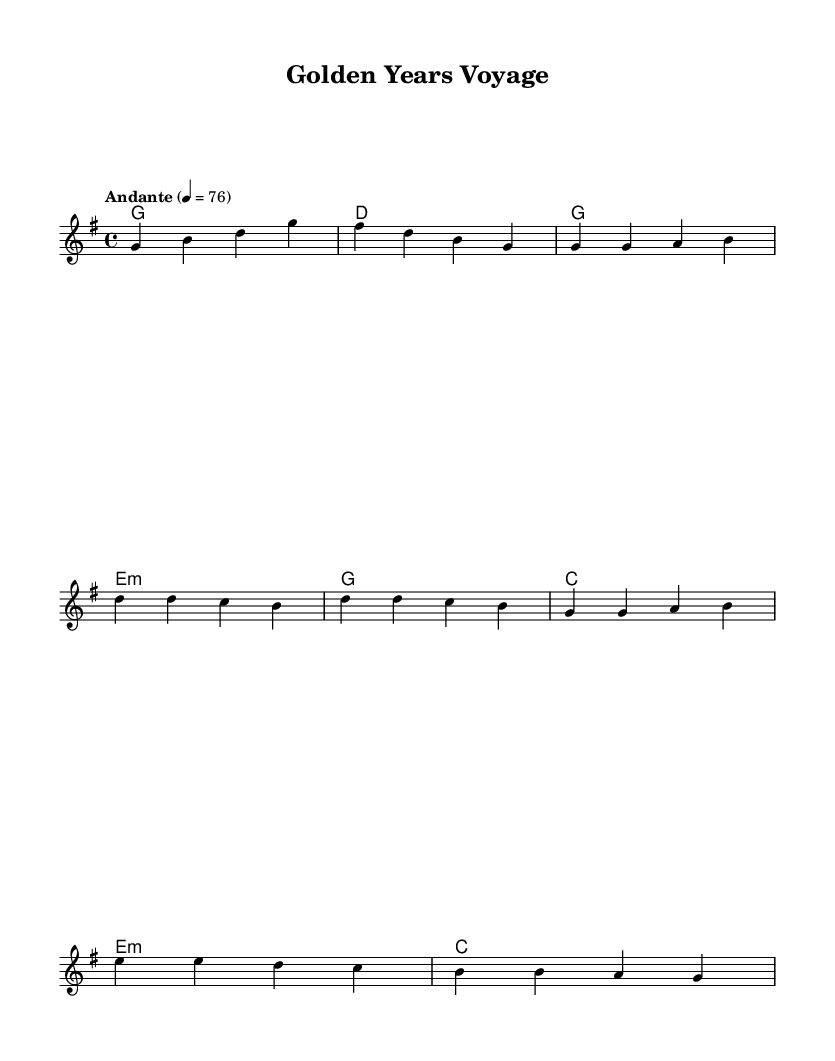What is the key signature of this music? The key signature is G major, which has one sharp (F#).
Answer: G major What is the time signature of this music? The time signature is 4/4, meaning there are four beats per measure.
Answer: 4/4 What is the tempo marking of this music? The tempo marking is Andante, indicated by the text "Andante" above the staff with a metronome mark of 76.
Answer: Andante How many measures are in the melody section provided? The melody consists of a total of 12 measures, as counted by the number of distinct phrases separated by bar lines.
Answer: 12 What is the chord played during the bridge section? The chord in the bridge section is E minor, as indicated in the chord names along with the melody.
Answer: E minor Which section contains the repeated melodic phrase? The chorus section contains a repeated melodic phrase, which is indicated by the similar notes progressing through that part of the music.
Answer: Chorus How does the harmony change from the intro to the verse? The harmony changes from G major in the intro to E minor in the verse, showing a shift in the tonal foundation of the piece.
Answer: G major to E minor 